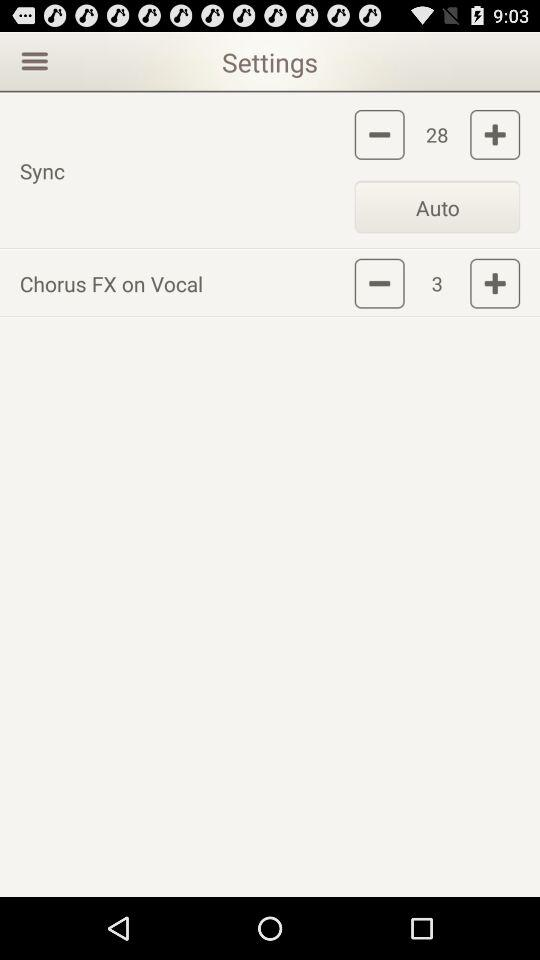Can we adjust numbers?
When the provided information is insufficient, respond with <no answer>. <no answer> 